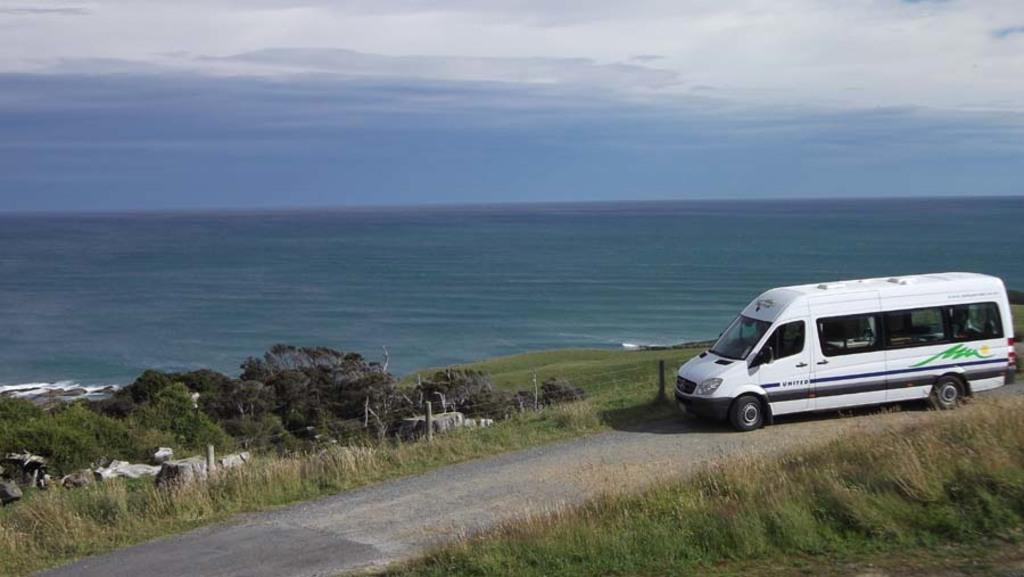What is on the road in the image? There is a vehicle on the road in the image. What can be seen in the background of the image? In the background of the image, there are stones, grass, fencing, trees, a sea, and sky. What is the condition of the sky in the image? The sky is visible in the background of the image, and there are clouds present. Can you tell me how many nuts are being used as expert advice in the image? There are no nuts or experts present in the image; it features a vehicle on the road and various elements in the background. Are there any giants visible in the image? There are no giants present in the image; it features a vehicle on the road and various elements in the background. 